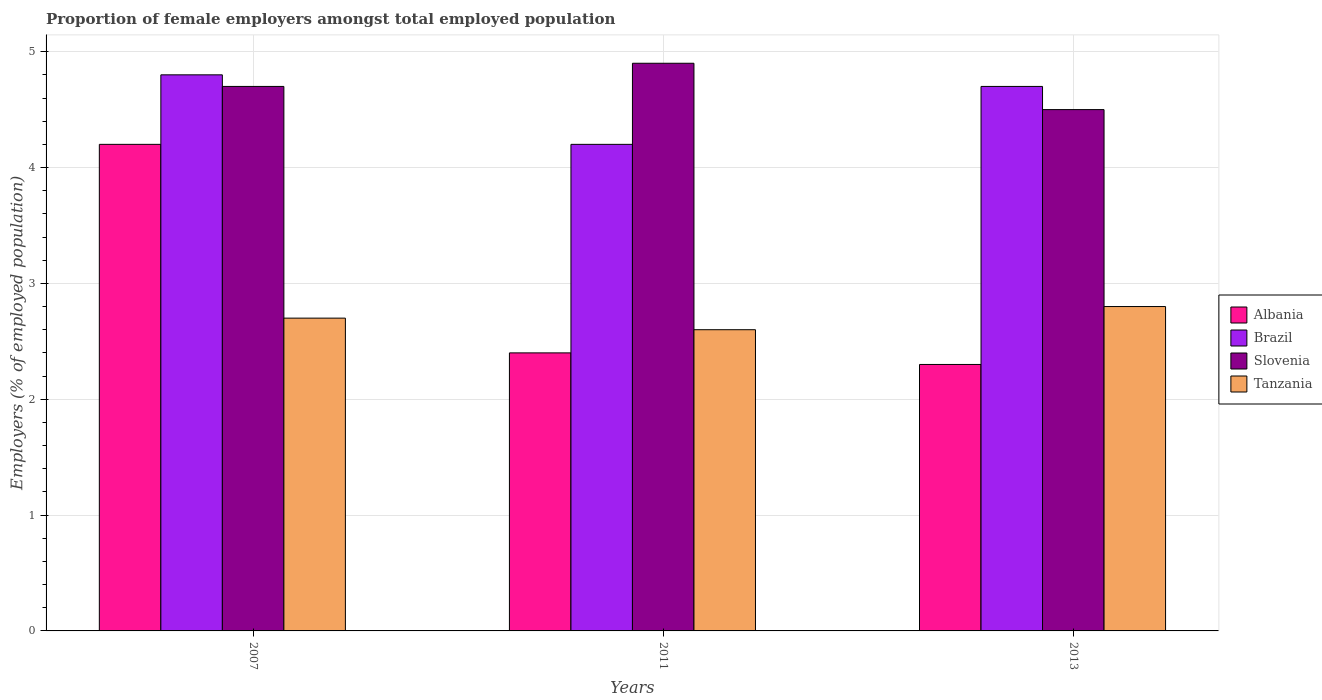How many different coloured bars are there?
Give a very brief answer. 4. How many groups of bars are there?
Keep it short and to the point. 3. Are the number of bars per tick equal to the number of legend labels?
Offer a very short reply. Yes. How many bars are there on the 2nd tick from the left?
Your answer should be compact. 4. How many bars are there on the 2nd tick from the right?
Your response must be concise. 4. What is the proportion of female employers in Slovenia in 2013?
Your answer should be very brief. 4.5. Across all years, what is the maximum proportion of female employers in Tanzania?
Ensure brevity in your answer.  2.8. In which year was the proportion of female employers in Slovenia minimum?
Ensure brevity in your answer.  2013. What is the total proportion of female employers in Brazil in the graph?
Your answer should be very brief. 13.7. What is the difference between the proportion of female employers in Brazil in 2007 and that in 2011?
Give a very brief answer. 0.6. What is the difference between the proportion of female employers in Albania in 2011 and the proportion of female employers in Slovenia in 2013?
Offer a terse response. -2.1. What is the average proportion of female employers in Brazil per year?
Keep it short and to the point. 4.57. In the year 2007, what is the difference between the proportion of female employers in Albania and proportion of female employers in Slovenia?
Offer a terse response. -0.5. What is the ratio of the proportion of female employers in Tanzania in 2007 to that in 2013?
Offer a terse response. 0.96. Is the proportion of female employers in Brazil in 2007 less than that in 2013?
Make the answer very short. No. Is the difference between the proportion of female employers in Albania in 2011 and 2013 greater than the difference between the proportion of female employers in Slovenia in 2011 and 2013?
Offer a terse response. No. What is the difference between the highest and the second highest proportion of female employers in Slovenia?
Your answer should be compact. 0.2. What is the difference between the highest and the lowest proportion of female employers in Slovenia?
Provide a short and direct response. 0.4. Is the sum of the proportion of female employers in Albania in 2007 and 2011 greater than the maximum proportion of female employers in Brazil across all years?
Give a very brief answer. Yes. Is it the case that in every year, the sum of the proportion of female employers in Albania and proportion of female employers in Tanzania is greater than the sum of proportion of female employers in Brazil and proportion of female employers in Slovenia?
Provide a short and direct response. No. What does the 2nd bar from the right in 2013 represents?
Your response must be concise. Slovenia. Is it the case that in every year, the sum of the proportion of female employers in Tanzania and proportion of female employers in Albania is greater than the proportion of female employers in Brazil?
Your answer should be compact. Yes. How many bars are there?
Keep it short and to the point. 12. Are all the bars in the graph horizontal?
Keep it short and to the point. No. How many years are there in the graph?
Keep it short and to the point. 3. Does the graph contain any zero values?
Your answer should be compact. No. Does the graph contain grids?
Provide a succinct answer. Yes. Where does the legend appear in the graph?
Make the answer very short. Center right. How are the legend labels stacked?
Ensure brevity in your answer.  Vertical. What is the title of the graph?
Offer a very short reply. Proportion of female employers amongst total employed population. What is the label or title of the Y-axis?
Ensure brevity in your answer.  Employers (% of employed population). What is the Employers (% of employed population) of Albania in 2007?
Offer a very short reply. 4.2. What is the Employers (% of employed population) in Brazil in 2007?
Make the answer very short. 4.8. What is the Employers (% of employed population) of Slovenia in 2007?
Keep it short and to the point. 4.7. What is the Employers (% of employed population) in Tanzania in 2007?
Your answer should be compact. 2.7. What is the Employers (% of employed population) of Albania in 2011?
Your response must be concise. 2.4. What is the Employers (% of employed population) of Brazil in 2011?
Give a very brief answer. 4.2. What is the Employers (% of employed population) in Slovenia in 2011?
Give a very brief answer. 4.9. What is the Employers (% of employed population) in Tanzania in 2011?
Your response must be concise. 2.6. What is the Employers (% of employed population) of Albania in 2013?
Provide a succinct answer. 2.3. What is the Employers (% of employed population) of Brazil in 2013?
Provide a succinct answer. 4.7. What is the Employers (% of employed population) of Slovenia in 2013?
Offer a very short reply. 4.5. What is the Employers (% of employed population) in Tanzania in 2013?
Offer a very short reply. 2.8. Across all years, what is the maximum Employers (% of employed population) of Albania?
Give a very brief answer. 4.2. Across all years, what is the maximum Employers (% of employed population) in Brazil?
Your answer should be very brief. 4.8. Across all years, what is the maximum Employers (% of employed population) of Slovenia?
Provide a succinct answer. 4.9. Across all years, what is the maximum Employers (% of employed population) of Tanzania?
Your answer should be very brief. 2.8. Across all years, what is the minimum Employers (% of employed population) of Albania?
Your answer should be compact. 2.3. Across all years, what is the minimum Employers (% of employed population) of Brazil?
Your answer should be compact. 4.2. Across all years, what is the minimum Employers (% of employed population) of Tanzania?
Offer a terse response. 2.6. What is the total Employers (% of employed population) of Albania in the graph?
Offer a very short reply. 8.9. What is the difference between the Employers (% of employed population) of Tanzania in 2007 and that in 2011?
Provide a succinct answer. 0.1. What is the difference between the Employers (% of employed population) in Slovenia in 2007 and that in 2013?
Make the answer very short. 0.2. What is the difference between the Employers (% of employed population) of Tanzania in 2007 and that in 2013?
Ensure brevity in your answer.  -0.1. What is the difference between the Employers (% of employed population) of Brazil in 2011 and that in 2013?
Offer a very short reply. -0.5. What is the difference between the Employers (% of employed population) of Tanzania in 2011 and that in 2013?
Your answer should be compact. -0.2. What is the difference between the Employers (% of employed population) of Albania in 2007 and the Employers (% of employed population) of Brazil in 2011?
Your answer should be compact. 0. What is the difference between the Employers (% of employed population) of Albania in 2007 and the Employers (% of employed population) of Slovenia in 2011?
Offer a very short reply. -0.7. What is the difference between the Employers (% of employed population) of Slovenia in 2007 and the Employers (% of employed population) of Tanzania in 2011?
Offer a terse response. 2.1. What is the difference between the Employers (% of employed population) of Albania in 2011 and the Employers (% of employed population) of Brazil in 2013?
Your response must be concise. -2.3. What is the difference between the Employers (% of employed population) in Albania in 2011 and the Employers (% of employed population) in Tanzania in 2013?
Provide a succinct answer. -0.4. What is the difference between the Employers (% of employed population) of Brazil in 2011 and the Employers (% of employed population) of Tanzania in 2013?
Provide a succinct answer. 1.4. What is the average Employers (% of employed population) in Albania per year?
Offer a very short reply. 2.97. What is the average Employers (% of employed population) in Brazil per year?
Provide a succinct answer. 4.57. What is the average Employers (% of employed population) in Tanzania per year?
Provide a short and direct response. 2.7. In the year 2007, what is the difference between the Employers (% of employed population) in Albania and Employers (% of employed population) in Brazil?
Provide a short and direct response. -0.6. In the year 2007, what is the difference between the Employers (% of employed population) in Albania and Employers (% of employed population) in Slovenia?
Your answer should be compact. -0.5. In the year 2007, what is the difference between the Employers (% of employed population) of Albania and Employers (% of employed population) of Tanzania?
Offer a very short reply. 1.5. In the year 2007, what is the difference between the Employers (% of employed population) of Brazil and Employers (% of employed population) of Slovenia?
Provide a succinct answer. 0.1. In the year 2007, what is the difference between the Employers (% of employed population) of Slovenia and Employers (% of employed population) of Tanzania?
Provide a short and direct response. 2. In the year 2011, what is the difference between the Employers (% of employed population) in Albania and Employers (% of employed population) in Brazil?
Ensure brevity in your answer.  -1.8. In the year 2011, what is the difference between the Employers (% of employed population) of Brazil and Employers (% of employed population) of Slovenia?
Provide a short and direct response. -0.7. In the year 2011, what is the difference between the Employers (% of employed population) in Brazil and Employers (% of employed population) in Tanzania?
Your response must be concise. 1.6. In the year 2011, what is the difference between the Employers (% of employed population) in Slovenia and Employers (% of employed population) in Tanzania?
Give a very brief answer. 2.3. In the year 2013, what is the difference between the Employers (% of employed population) in Albania and Employers (% of employed population) in Brazil?
Your response must be concise. -2.4. In the year 2013, what is the difference between the Employers (% of employed population) in Brazil and Employers (% of employed population) in Tanzania?
Provide a short and direct response. 1.9. In the year 2013, what is the difference between the Employers (% of employed population) in Slovenia and Employers (% of employed population) in Tanzania?
Ensure brevity in your answer.  1.7. What is the ratio of the Employers (% of employed population) in Brazil in 2007 to that in 2011?
Give a very brief answer. 1.14. What is the ratio of the Employers (% of employed population) in Slovenia in 2007 to that in 2011?
Provide a succinct answer. 0.96. What is the ratio of the Employers (% of employed population) in Albania in 2007 to that in 2013?
Provide a succinct answer. 1.83. What is the ratio of the Employers (% of employed population) in Brazil in 2007 to that in 2013?
Give a very brief answer. 1.02. What is the ratio of the Employers (% of employed population) of Slovenia in 2007 to that in 2013?
Provide a short and direct response. 1.04. What is the ratio of the Employers (% of employed population) in Tanzania in 2007 to that in 2013?
Ensure brevity in your answer.  0.96. What is the ratio of the Employers (% of employed population) in Albania in 2011 to that in 2013?
Give a very brief answer. 1.04. What is the ratio of the Employers (% of employed population) of Brazil in 2011 to that in 2013?
Keep it short and to the point. 0.89. What is the ratio of the Employers (% of employed population) of Slovenia in 2011 to that in 2013?
Make the answer very short. 1.09. What is the ratio of the Employers (% of employed population) of Tanzania in 2011 to that in 2013?
Offer a very short reply. 0.93. What is the difference between the highest and the second highest Employers (% of employed population) in Albania?
Your answer should be compact. 1.8. What is the difference between the highest and the second highest Employers (% of employed population) of Brazil?
Keep it short and to the point. 0.1. What is the difference between the highest and the lowest Employers (% of employed population) in Albania?
Your answer should be compact. 1.9. What is the difference between the highest and the lowest Employers (% of employed population) of Tanzania?
Give a very brief answer. 0.2. 